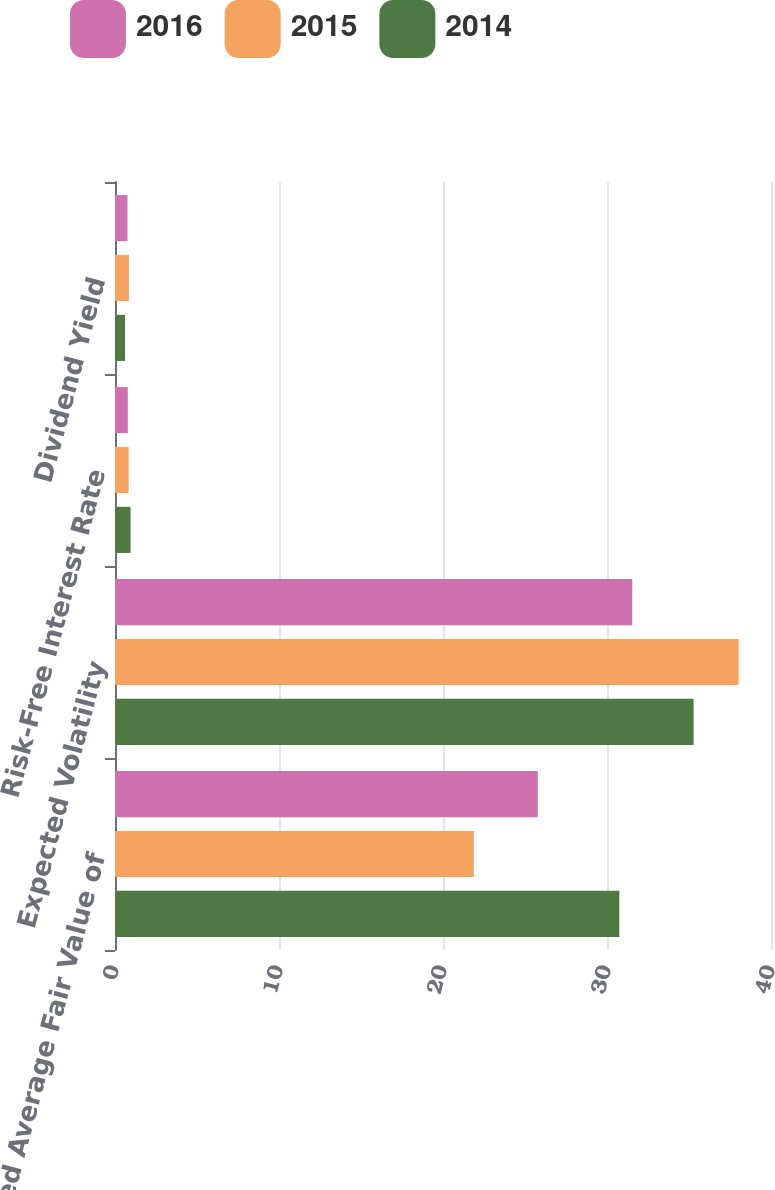Convert chart to OTSL. <chart><loc_0><loc_0><loc_500><loc_500><stacked_bar_chart><ecel><fcel>Weighted Average Fair Value of<fcel>Expected Volatility<fcel>Risk-Free Interest Rate<fcel>Dividend Yield<nl><fcel>2016<fcel>25.78<fcel>31.54<fcel>0.78<fcel>0.76<nl><fcel>2015<fcel>21.88<fcel>38.03<fcel>0.83<fcel>0.85<nl><fcel>2014<fcel>30.75<fcel>35.28<fcel>0.95<fcel>0.61<nl></chart> 